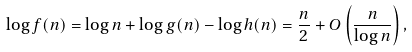Convert formula to latex. <formula><loc_0><loc_0><loc_500><loc_500>\log f ( n ) = \log n + \log g ( n ) - \log h ( n ) = \frac { n } { 2 } + O \left ( \frac { n } { \log n } \right ) ,</formula> 